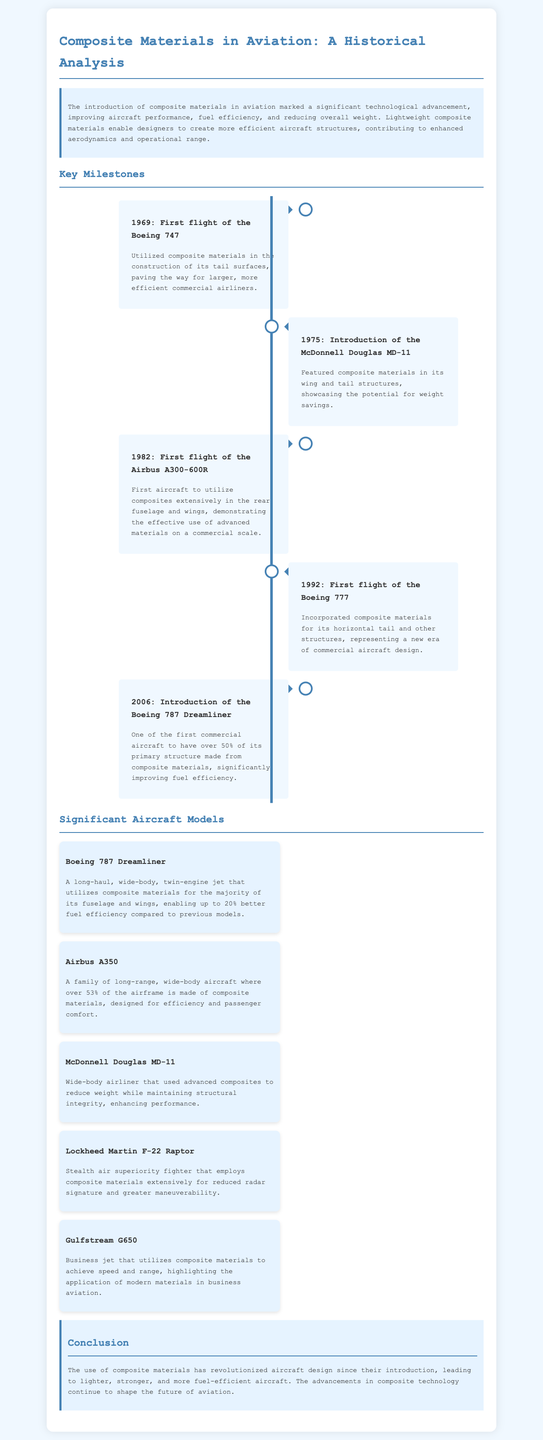What year did the Boeing 747 have its first flight? The document lists the first flight of the Boeing 747 as a key milestone in 1969.
Answer: 1969 Which aircraft was the first to utilize composites extensively in the rear fuselage and wings? The document identifies the Airbus A300-600R as the first aircraft to use composites extensively in those areas.
Answer: Airbus A300-600R What percentage of the Boeing 787 Dreamliner's primary structure is made from composite materials? The document states that over 50% of the primary structure of the Boeing 787 Dreamliner is made from composite materials.
Answer: Over 50% What significant feature does the Lockheed Martin F-22 Raptor utilize composites for? The document mentions that the F-22 Raptor employs composite materials extensively for reduced radar signature.
Answer: Reduced radar signature Which year marks the introduction of the Boeing 787 Dreamliner? The text specifies that the Boeing 787 Dreamliner was introduced in 2006.
Answer: 2006 What was a major benefit of using composite materials in the McDonnell Douglas MD-11? The document highlights that the use of advanced composites reduced weight while maintaining structural integrity in the MD-11.
Answer: Reduced weight Which aircraft's airframe is made of over 53% composite materials? The document states that the Airbus A350 has over 53% of its airframe made from composite materials.
Answer: Airbus A350 What is the primary focus of the document? The document analyzes the historical significance and impact of composite materials in aviation.
Answer: Historical significance of composite materials 